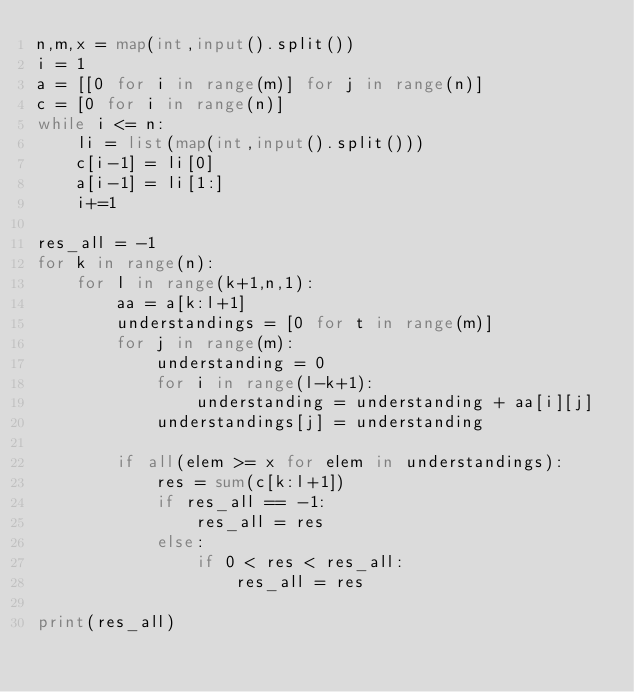Convert code to text. <code><loc_0><loc_0><loc_500><loc_500><_Python_>n,m,x = map(int,input().split())
i = 1
a = [[0 for i in range(m)] for j in range(n)]
c = [0 for i in range(n)]
while i <= n:
    li = list(map(int,input().split()))
    c[i-1] = li[0]
    a[i-1] = li[1:]
    i+=1

res_all = -1
for k in range(n):
    for l in range(k+1,n,1):
        aa = a[k:l+1]
        understandings = [0 for t in range(m)]
        for j in range(m):
            understanding = 0
            for i in range(l-k+1):
                understanding = understanding + aa[i][j]
            understandings[j] = understanding
        
        if all(elem >= x for elem in understandings):
            res = sum(c[k:l+1])
            if res_all == -1:
                res_all = res
            else:
                if 0 < res < res_all:
                    res_all = res

print(res_all)</code> 